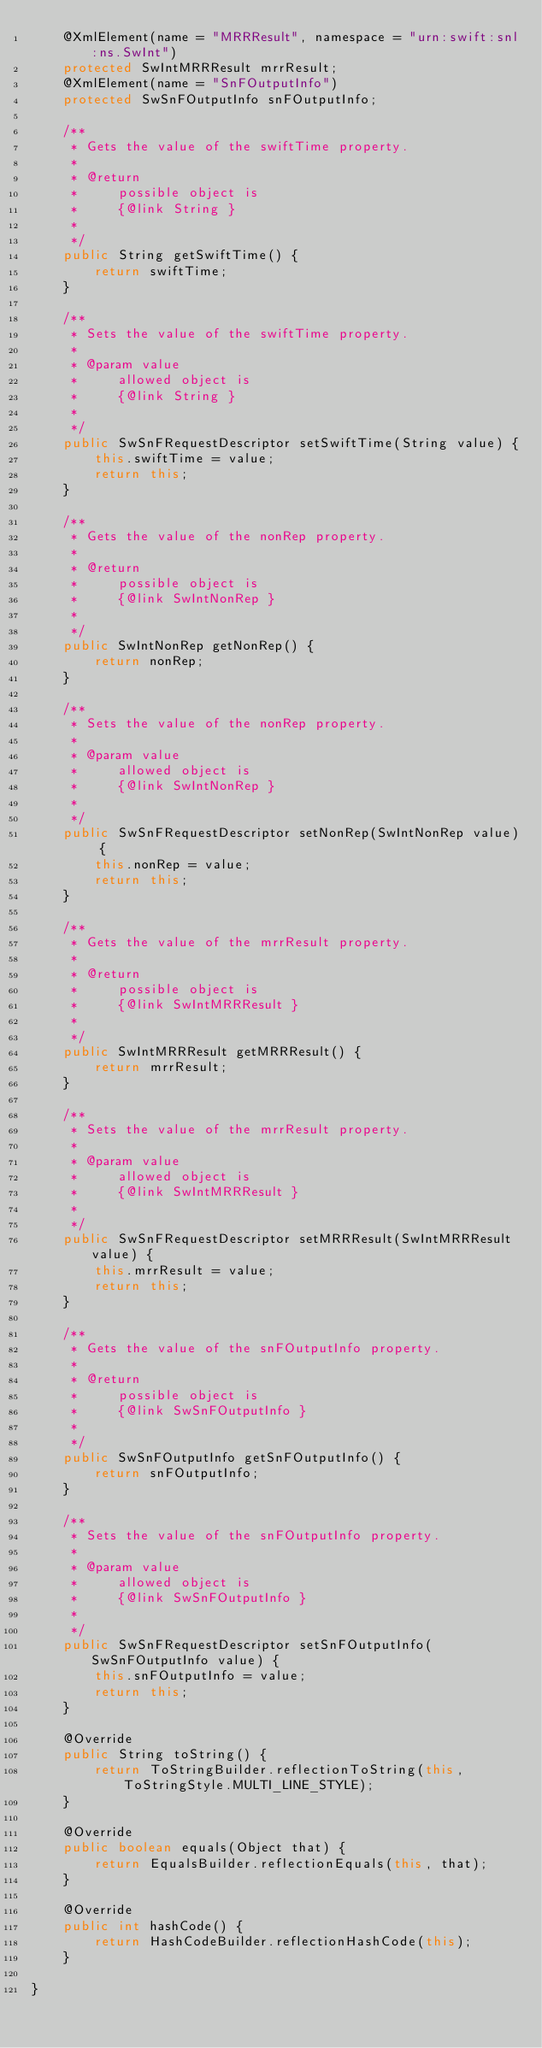<code> <loc_0><loc_0><loc_500><loc_500><_Java_>    @XmlElement(name = "MRRResult", namespace = "urn:swift:snl:ns.SwInt")
    protected SwIntMRRResult mrrResult;
    @XmlElement(name = "SnFOutputInfo")
    protected SwSnFOutputInfo snFOutputInfo;

    /**
     * Gets the value of the swiftTime property.
     * 
     * @return
     *     possible object is
     *     {@link String }
     *     
     */
    public String getSwiftTime() {
        return swiftTime;
    }

    /**
     * Sets the value of the swiftTime property.
     * 
     * @param value
     *     allowed object is
     *     {@link String }
     *     
     */
    public SwSnFRequestDescriptor setSwiftTime(String value) {
        this.swiftTime = value;
        return this;
    }

    /**
     * Gets the value of the nonRep property.
     * 
     * @return
     *     possible object is
     *     {@link SwIntNonRep }
     *     
     */
    public SwIntNonRep getNonRep() {
        return nonRep;
    }

    /**
     * Sets the value of the nonRep property.
     * 
     * @param value
     *     allowed object is
     *     {@link SwIntNonRep }
     *     
     */
    public SwSnFRequestDescriptor setNonRep(SwIntNonRep value) {
        this.nonRep = value;
        return this;
    }

    /**
     * Gets the value of the mrrResult property.
     * 
     * @return
     *     possible object is
     *     {@link SwIntMRRResult }
     *     
     */
    public SwIntMRRResult getMRRResult() {
        return mrrResult;
    }

    /**
     * Sets the value of the mrrResult property.
     * 
     * @param value
     *     allowed object is
     *     {@link SwIntMRRResult }
     *     
     */
    public SwSnFRequestDescriptor setMRRResult(SwIntMRRResult value) {
        this.mrrResult = value;
        return this;
    }

    /**
     * Gets the value of the snFOutputInfo property.
     * 
     * @return
     *     possible object is
     *     {@link SwSnFOutputInfo }
     *     
     */
    public SwSnFOutputInfo getSnFOutputInfo() {
        return snFOutputInfo;
    }

    /**
     * Sets the value of the snFOutputInfo property.
     * 
     * @param value
     *     allowed object is
     *     {@link SwSnFOutputInfo }
     *     
     */
    public SwSnFRequestDescriptor setSnFOutputInfo(SwSnFOutputInfo value) {
        this.snFOutputInfo = value;
        return this;
    }

    @Override
    public String toString() {
        return ToStringBuilder.reflectionToString(this, ToStringStyle.MULTI_LINE_STYLE);
    }

    @Override
    public boolean equals(Object that) {
        return EqualsBuilder.reflectionEquals(this, that);
    }

    @Override
    public int hashCode() {
        return HashCodeBuilder.reflectionHashCode(this);
    }

}
</code> 